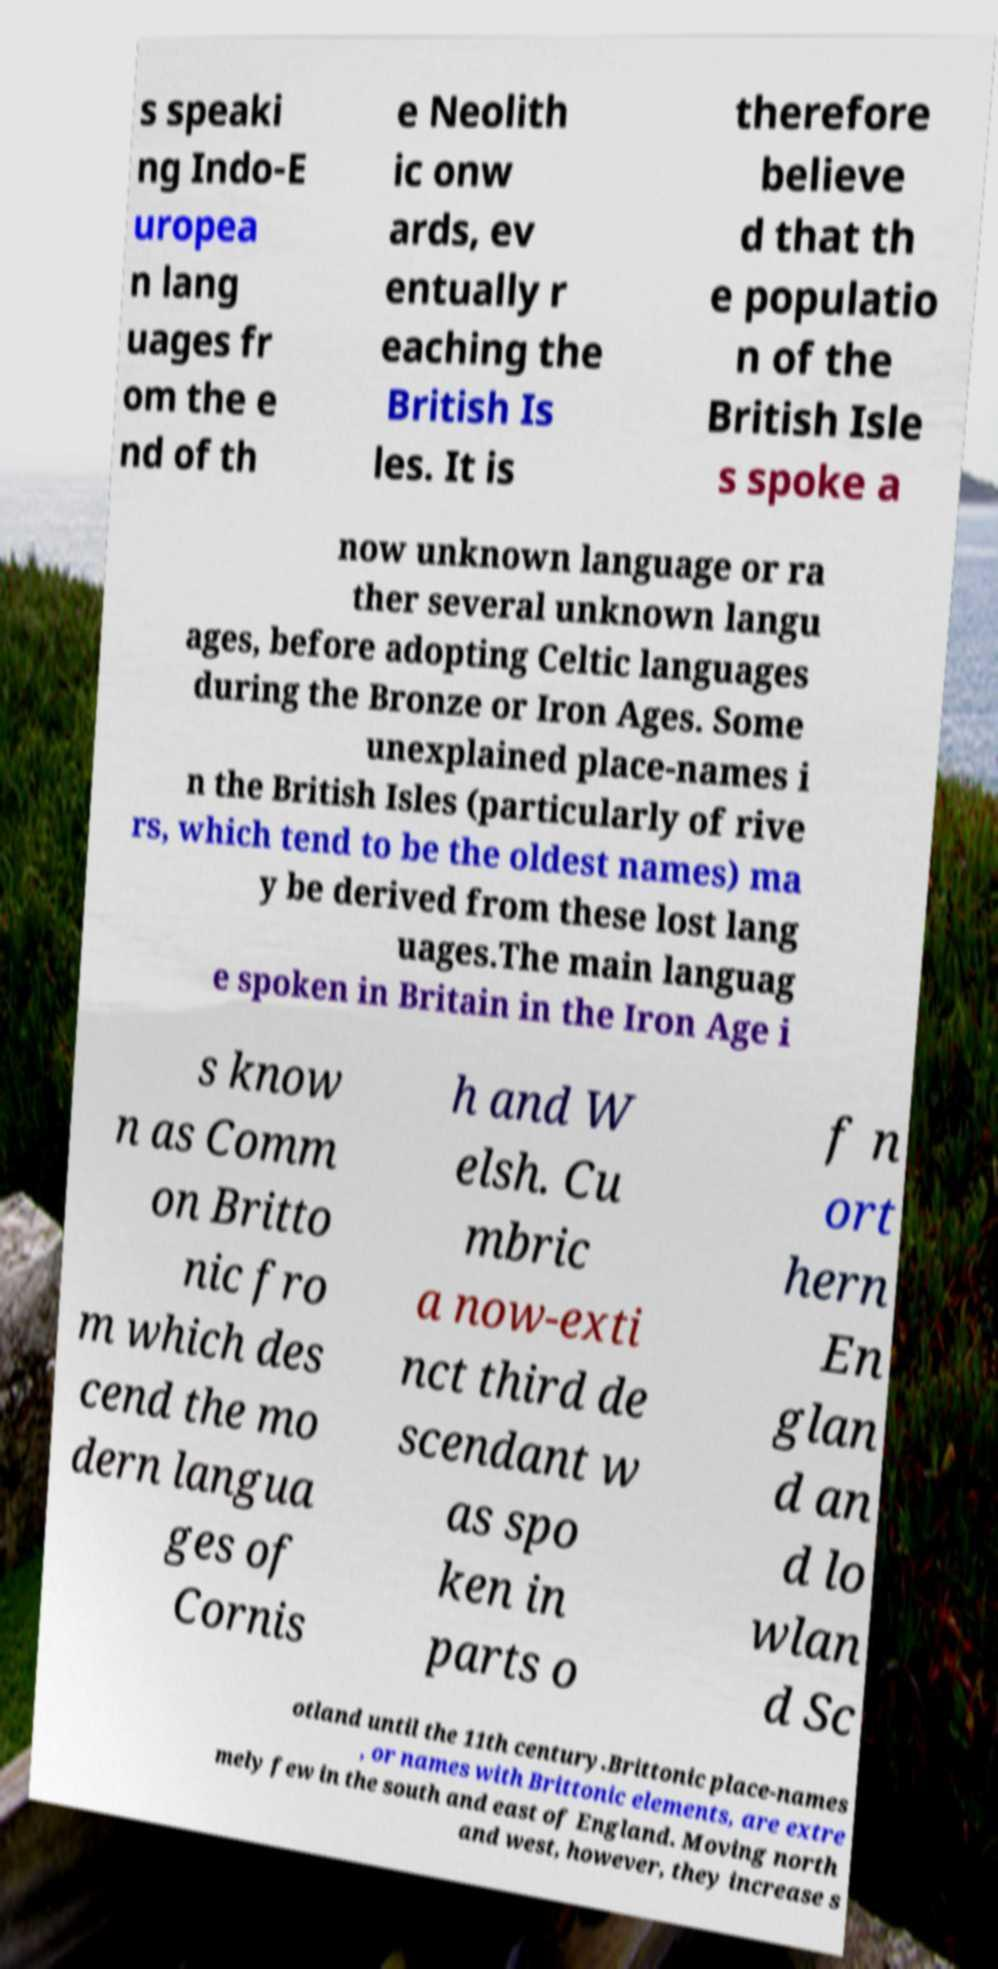Please identify and transcribe the text found in this image. s speaki ng Indo-E uropea n lang uages fr om the e nd of th e Neolith ic onw ards, ev entually r eaching the British Is les. It is therefore believe d that th e populatio n of the British Isle s spoke a now unknown language or ra ther several unknown langu ages, before adopting Celtic languages during the Bronze or Iron Ages. Some unexplained place-names i n the British Isles (particularly of rive rs, which tend to be the oldest names) ma y be derived from these lost lang uages.The main languag e spoken in Britain in the Iron Age i s know n as Comm on Britto nic fro m which des cend the mo dern langua ges of Cornis h and W elsh. Cu mbric a now-exti nct third de scendant w as spo ken in parts o f n ort hern En glan d an d lo wlan d Sc otland until the 11th century.Brittonic place-names , or names with Brittonic elements, are extre mely few in the south and east of England. Moving north and west, however, they increase s 